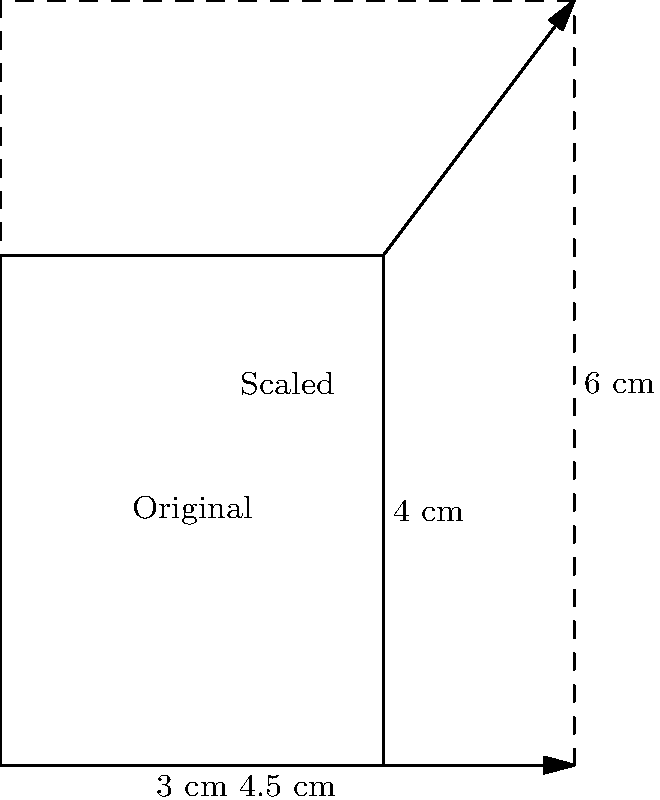As a tennis coach designing a new racket, you want to scale up an existing rectangular frame design. The original design has dimensions of 3 cm by 4 cm. If you want the new design to have a width of 4.5 cm while maintaining the same proportions, what will be the height of the scaled design? Round your answer to the nearest tenth of a centimeter. To solve this problem, we'll use the concept of scaling in transformational geometry. Here's a step-by-step approach:

1) First, let's identify the scale factor. We can find this by dividing the new width by the original width:
   Scale factor = New width / Original width
   $$ \text{Scale factor} = \frac{4.5 \text{ cm}}{3 \text{ cm}} = 1.5 $$

2) This means that all dimensions of the original design will be multiplied by 1.5 to get the new dimensions.

3) Now, let's apply this scale factor to the height:
   New height = Original height × Scale factor
   $$ \text{New height} = 4 \text{ cm} \times 1.5 = 6 \text{ cm} $$

4) Therefore, the height of the scaled design will be 6 cm.

5) The question asks to round to the nearest tenth of a centimeter, but 6 cm is already in that form.

This scaling preserves the aspect ratio of the original design, ensuring that the new racket frame maintains the same proportions as the original.
Answer: 6 cm 